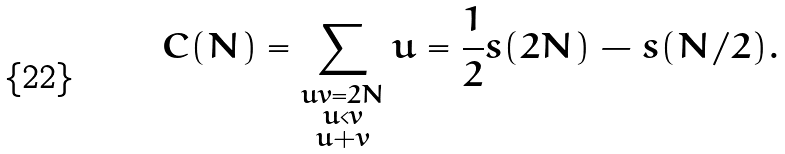Convert formula to latex. <formula><loc_0><loc_0><loc_500><loc_500>C ( N ) = \sum _ { \substack { u v = 2 N \\ u < v \\ u + v } } u = \frac { 1 } { 2 } s ( 2 N ) - s ( N / 2 ) .</formula> 